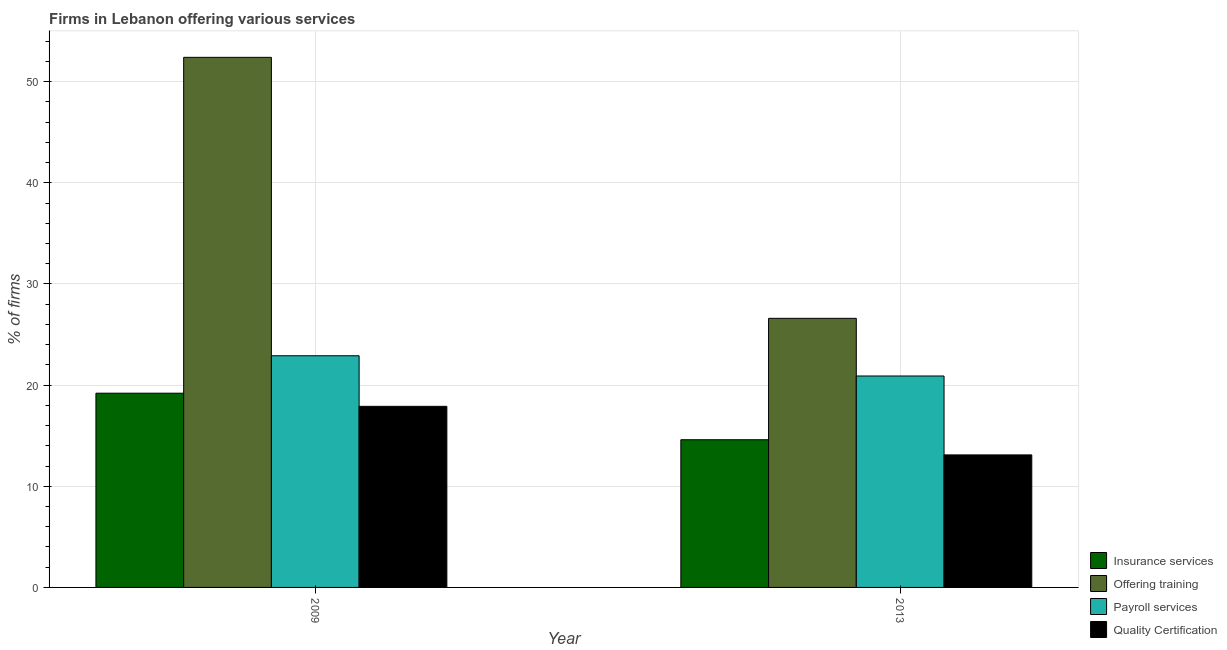How many different coloured bars are there?
Offer a terse response. 4. Are the number of bars on each tick of the X-axis equal?
Your answer should be very brief. Yes. How many bars are there on the 2nd tick from the left?
Provide a short and direct response. 4. How many bars are there on the 1st tick from the right?
Offer a very short reply. 4. What is the label of the 2nd group of bars from the left?
Your answer should be compact. 2013. What is the difference between the percentage of firms offering quality certification in 2009 and that in 2013?
Offer a terse response. 4.8. What is the difference between the percentage of firms offering quality certification in 2009 and the percentage of firms offering insurance services in 2013?
Make the answer very short. 4.8. What is the average percentage of firms offering payroll services per year?
Make the answer very short. 21.9. What is the ratio of the percentage of firms offering quality certification in 2009 to that in 2013?
Offer a very short reply. 1.37. In how many years, is the percentage of firms offering payroll services greater than the average percentage of firms offering payroll services taken over all years?
Offer a terse response. 1. Is it the case that in every year, the sum of the percentage of firms offering insurance services and percentage of firms offering quality certification is greater than the sum of percentage of firms offering training and percentage of firms offering payroll services?
Keep it short and to the point. No. What does the 3rd bar from the left in 2013 represents?
Your answer should be very brief. Payroll services. What does the 4th bar from the right in 2009 represents?
Keep it short and to the point. Insurance services. Is it the case that in every year, the sum of the percentage of firms offering insurance services and percentage of firms offering training is greater than the percentage of firms offering payroll services?
Provide a short and direct response. Yes. How many bars are there?
Provide a short and direct response. 8. Are all the bars in the graph horizontal?
Provide a short and direct response. No. Are the values on the major ticks of Y-axis written in scientific E-notation?
Make the answer very short. No. Does the graph contain grids?
Offer a terse response. Yes. What is the title of the graph?
Offer a very short reply. Firms in Lebanon offering various services . Does "Coal" appear as one of the legend labels in the graph?
Provide a short and direct response. No. What is the label or title of the Y-axis?
Provide a short and direct response. % of firms. What is the % of firms in Insurance services in 2009?
Provide a short and direct response. 19.2. What is the % of firms in Offering training in 2009?
Provide a succinct answer. 52.4. What is the % of firms of Payroll services in 2009?
Keep it short and to the point. 22.9. What is the % of firms of Offering training in 2013?
Ensure brevity in your answer.  26.6. What is the % of firms in Payroll services in 2013?
Your answer should be very brief. 20.9. What is the % of firms of Quality Certification in 2013?
Give a very brief answer. 13.1. Across all years, what is the maximum % of firms of Offering training?
Your response must be concise. 52.4. Across all years, what is the maximum % of firms of Payroll services?
Your answer should be compact. 22.9. Across all years, what is the maximum % of firms of Quality Certification?
Make the answer very short. 17.9. Across all years, what is the minimum % of firms in Insurance services?
Offer a terse response. 14.6. Across all years, what is the minimum % of firms of Offering training?
Offer a terse response. 26.6. Across all years, what is the minimum % of firms of Payroll services?
Ensure brevity in your answer.  20.9. What is the total % of firms in Insurance services in the graph?
Your answer should be very brief. 33.8. What is the total % of firms of Offering training in the graph?
Your answer should be compact. 79. What is the total % of firms in Payroll services in the graph?
Make the answer very short. 43.8. What is the difference between the % of firms of Insurance services in 2009 and that in 2013?
Your answer should be compact. 4.6. What is the difference between the % of firms in Offering training in 2009 and that in 2013?
Provide a succinct answer. 25.8. What is the difference between the % of firms of Quality Certification in 2009 and that in 2013?
Your answer should be compact. 4.8. What is the difference between the % of firms of Insurance services in 2009 and the % of firms of Payroll services in 2013?
Offer a terse response. -1.7. What is the difference between the % of firms in Offering training in 2009 and the % of firms in Payroll services in 2013?
Your answer should be very brief. 31.5. What is the difference between the % of firms in Offering training in 2009 and the % of firms in Quality Certification in 2013?
Keep it short and to the point. 39.3. What is the difference between the % of firms of Payroll services in 2009 and the % of firms of Quality Certification in 2013?
Keep it short and to the point. 9.8. What is the average % of firms in Insurance services per year?
Offer a terse response. 16.9. What is the average % of firms in Offering training per year?
Give a very brief answer. 39.5. What is the average % of firms in Payroll services per year?
Offer a very short reply. 21.9. What is the average % of firms of Quality Certification per year?
Your answer should be compact. 15.5. In the year 2009, what is the difference between the % of firms in Insurance services and % of firms in Offering training?
Offer a terse response. -33.2. In the year 2009, what is the difference between the % of firms in Offering training and % of firms in Payroll services?
Ensure brevity in your answer.  29.5. In the year 2009, what is the difference between the % of firms in Offering training and % of firms in Quality Certification?
Make the answer very short. 34.5. In the year 2013, what is the difference between the % of firms of Offering training and % of firms of Payroll services?
Offer a very short reply. 5.7. In the year 2013, what is the difference between the % of firms of Offering training and % of firms of Quality Certification?
Make the answer very short. 13.5. What is the ratio of the % of firms of Insurance services in 2009 to that in 2013?
Provide a succinct answer. 1.32. What is the ratio of the % of firms of Offering training in 2009 to that in 2013?
Keep it short and to the point. 1.97. What is the ratio of the % of firms in Payroll services in 2009 to that in 2013?
Ensure brevity in your answer.  1.1. What is the ratio of the % of firms in Quality Certification in 2009 to that in 2013?
Ensure brevity in your answer.  1.37. What is the difference between the highest and the second highest % of firms in Insurance services?
Ensure brevity in your answer.  4.6. What is the difference between the highest and the second highest % of firms of Offering training?
Offer a terse response. 25.8. What is the difference between the highest and the second highest % of firms in Payroll services?
Keep it short and to the point. 2. What is the difference between the highest and the lowest % of firms of Offering training?
Offer a terse response. 25.8. What is the difference between the highest and the lowest % of firms of Quality Certification?
Provide a short and direct response. 4.8. 